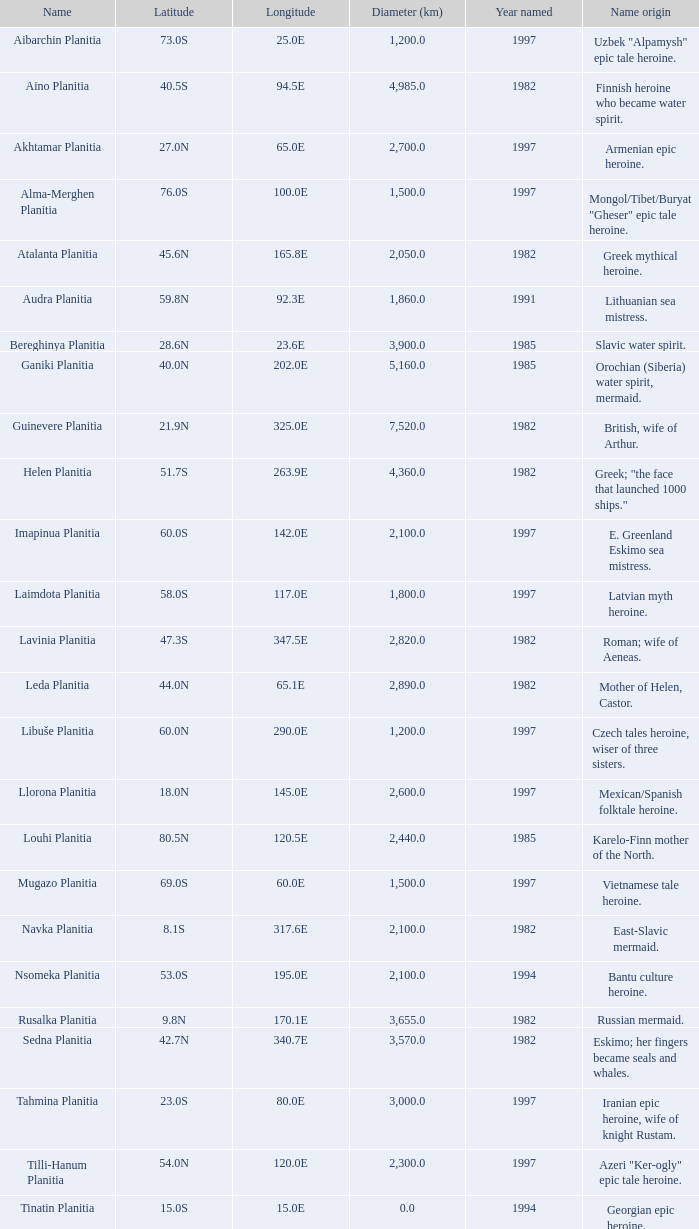What is the latitude of the characteristic at longitude 8 23.0S. 